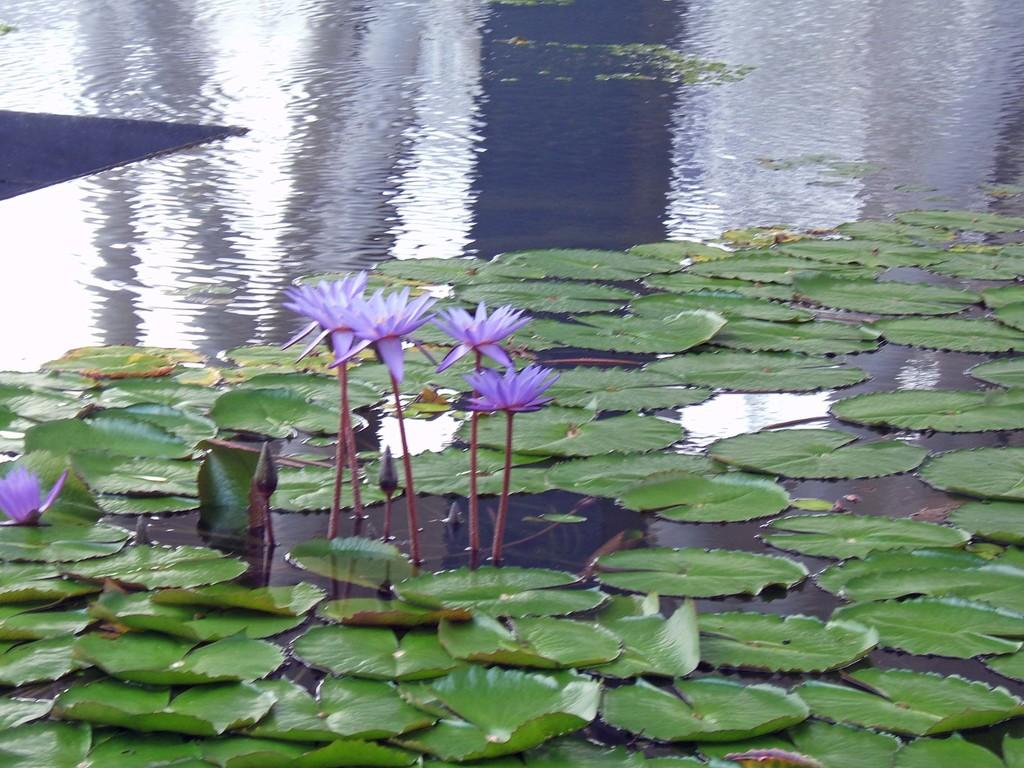What is the primary element visible in the image? There is water in the image. What can be found floating in the water? There are leaves and lotus flowers in the water. What is the color of the lotus flowers? The lotus flowers are violet in color. What is the opinion of the snake about the lotus flowers in the image? There is no snake present in the image, so it is not possible to determine its opinion about the lotus flowers. 